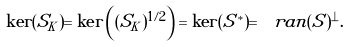<formula> <loc_0><loc_0><loc_500><loc_500>\ker ( S _ { K } ) = \ker \left ( ( S _ { K } ) ^ { 1 / 2 } \right ) = \ker ( S ^ { * } ) = \ r a n ( S ) ^ { \bot } .</formula> 